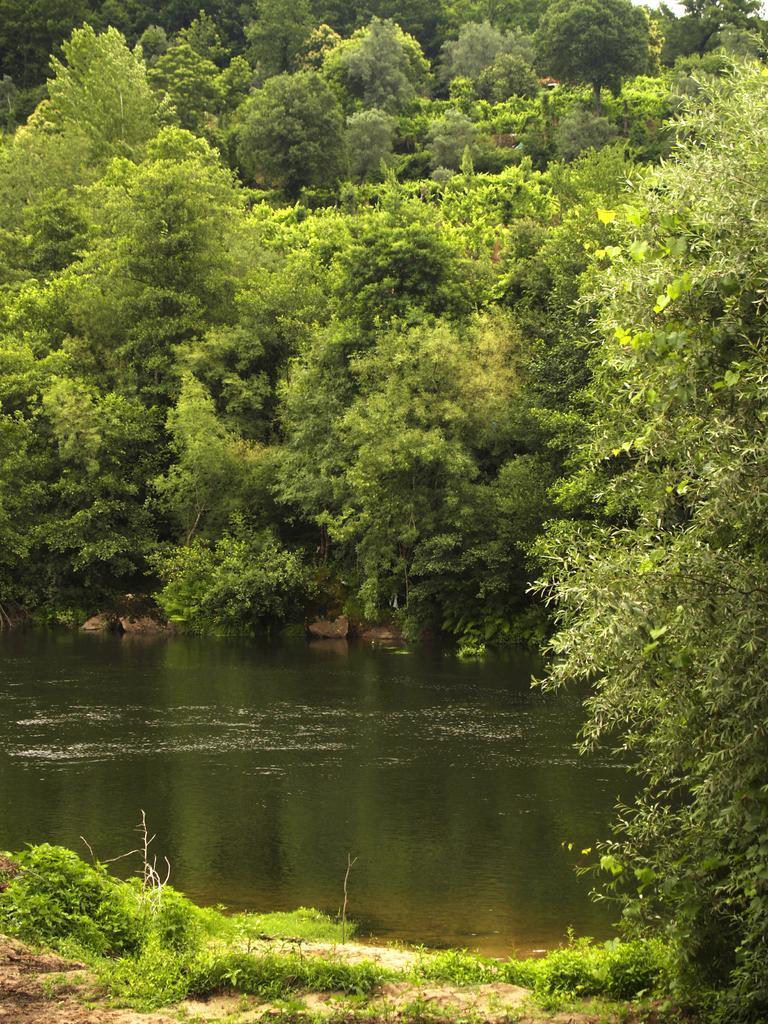In one or two sentences, can you explain what this image depicts? On the right side, there is a tree on the ground on which, there are plants and grass. In the background, there is water of a river, there are trees and plants. 